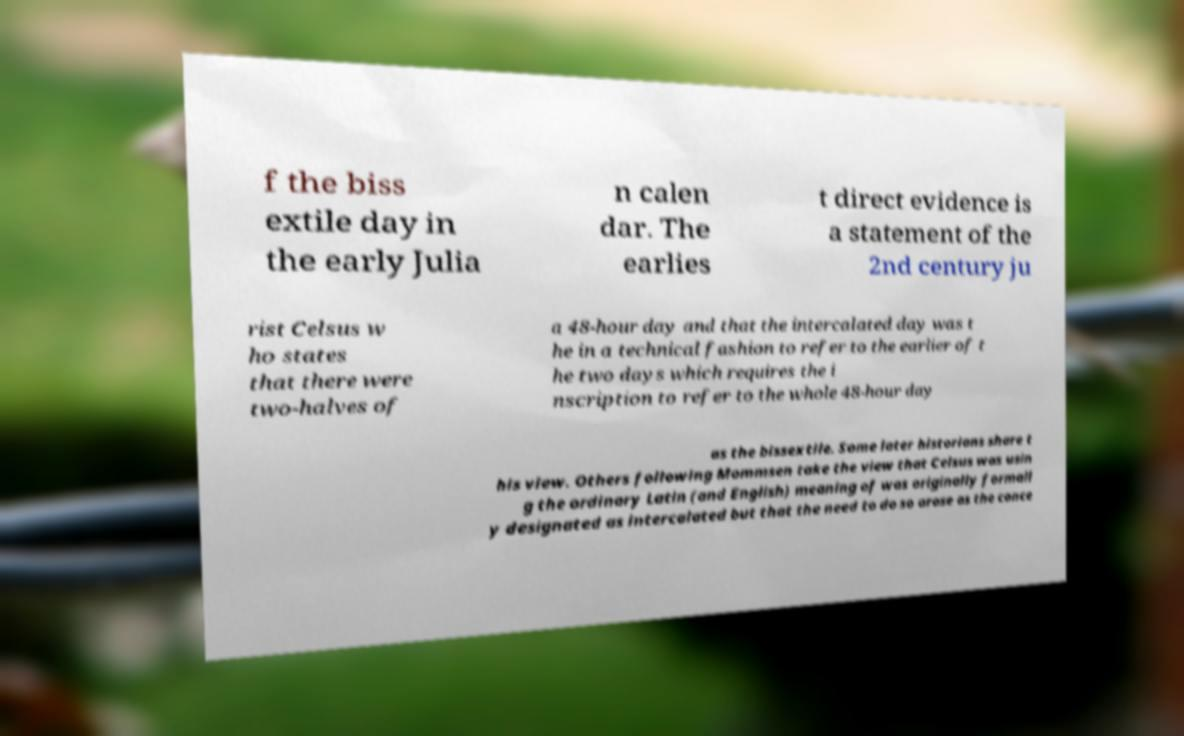For documentation purposes, I need the text within this image transcribed. Could you provide that? f the biss extile day in the early Julia n calen dar. The earlies t direct evidence is a statement of the 2nd century ju rist Celsus w ho states that there were two-halves of a 48-hour day and that the intercalated day was t he in a technical fashion to refer to the earlier of t he two days which requires the i nscription to refer to the whole 48-hour day as the bissextile. Some later historians share t his view. Others following Mommsen take the view that Celsus was usin g the ordinary Latin (and English) meaning of was originally formall y designated as intercalated but that the need to do so arose as the conce 